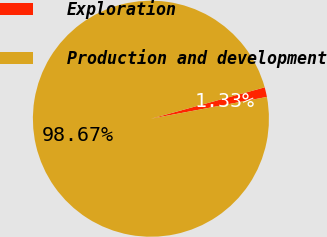<chart> <loc_0><loc_0><loc_500><loc_500><pie_chart><fcel>Exploration<fcel>Production and development<nl><fcel>1.33%<fcel>98.67%<nl></chart> 